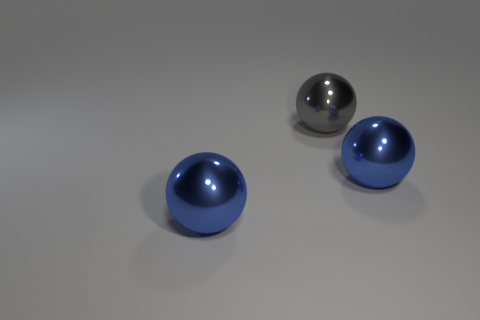Add 3 large spheres. How many objects exist? 6 Subtract all gray shiny balls. Subtract all tiny yellow metallic cylinders. How many objects are left? 2 Add 1 blue shiny balls. How many blue shiny balls are left? 3 Add 2 red cubes. How many red cubes exist? 2 Subtract 0 blue cylinders. How many objects are left? 3 